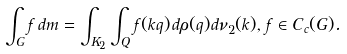Convert formula to latex. <formula><loc_0><loc_0><loc_500><loc_500>\int _ { G } f \, d m = \int _ { K _ { 2 } } \int _ { Q } f ( k q ) \, d \rho ( q ) d \nu _ { 2 } ( k ) , \, f \in C _ { c } ( G ) .</formula> 